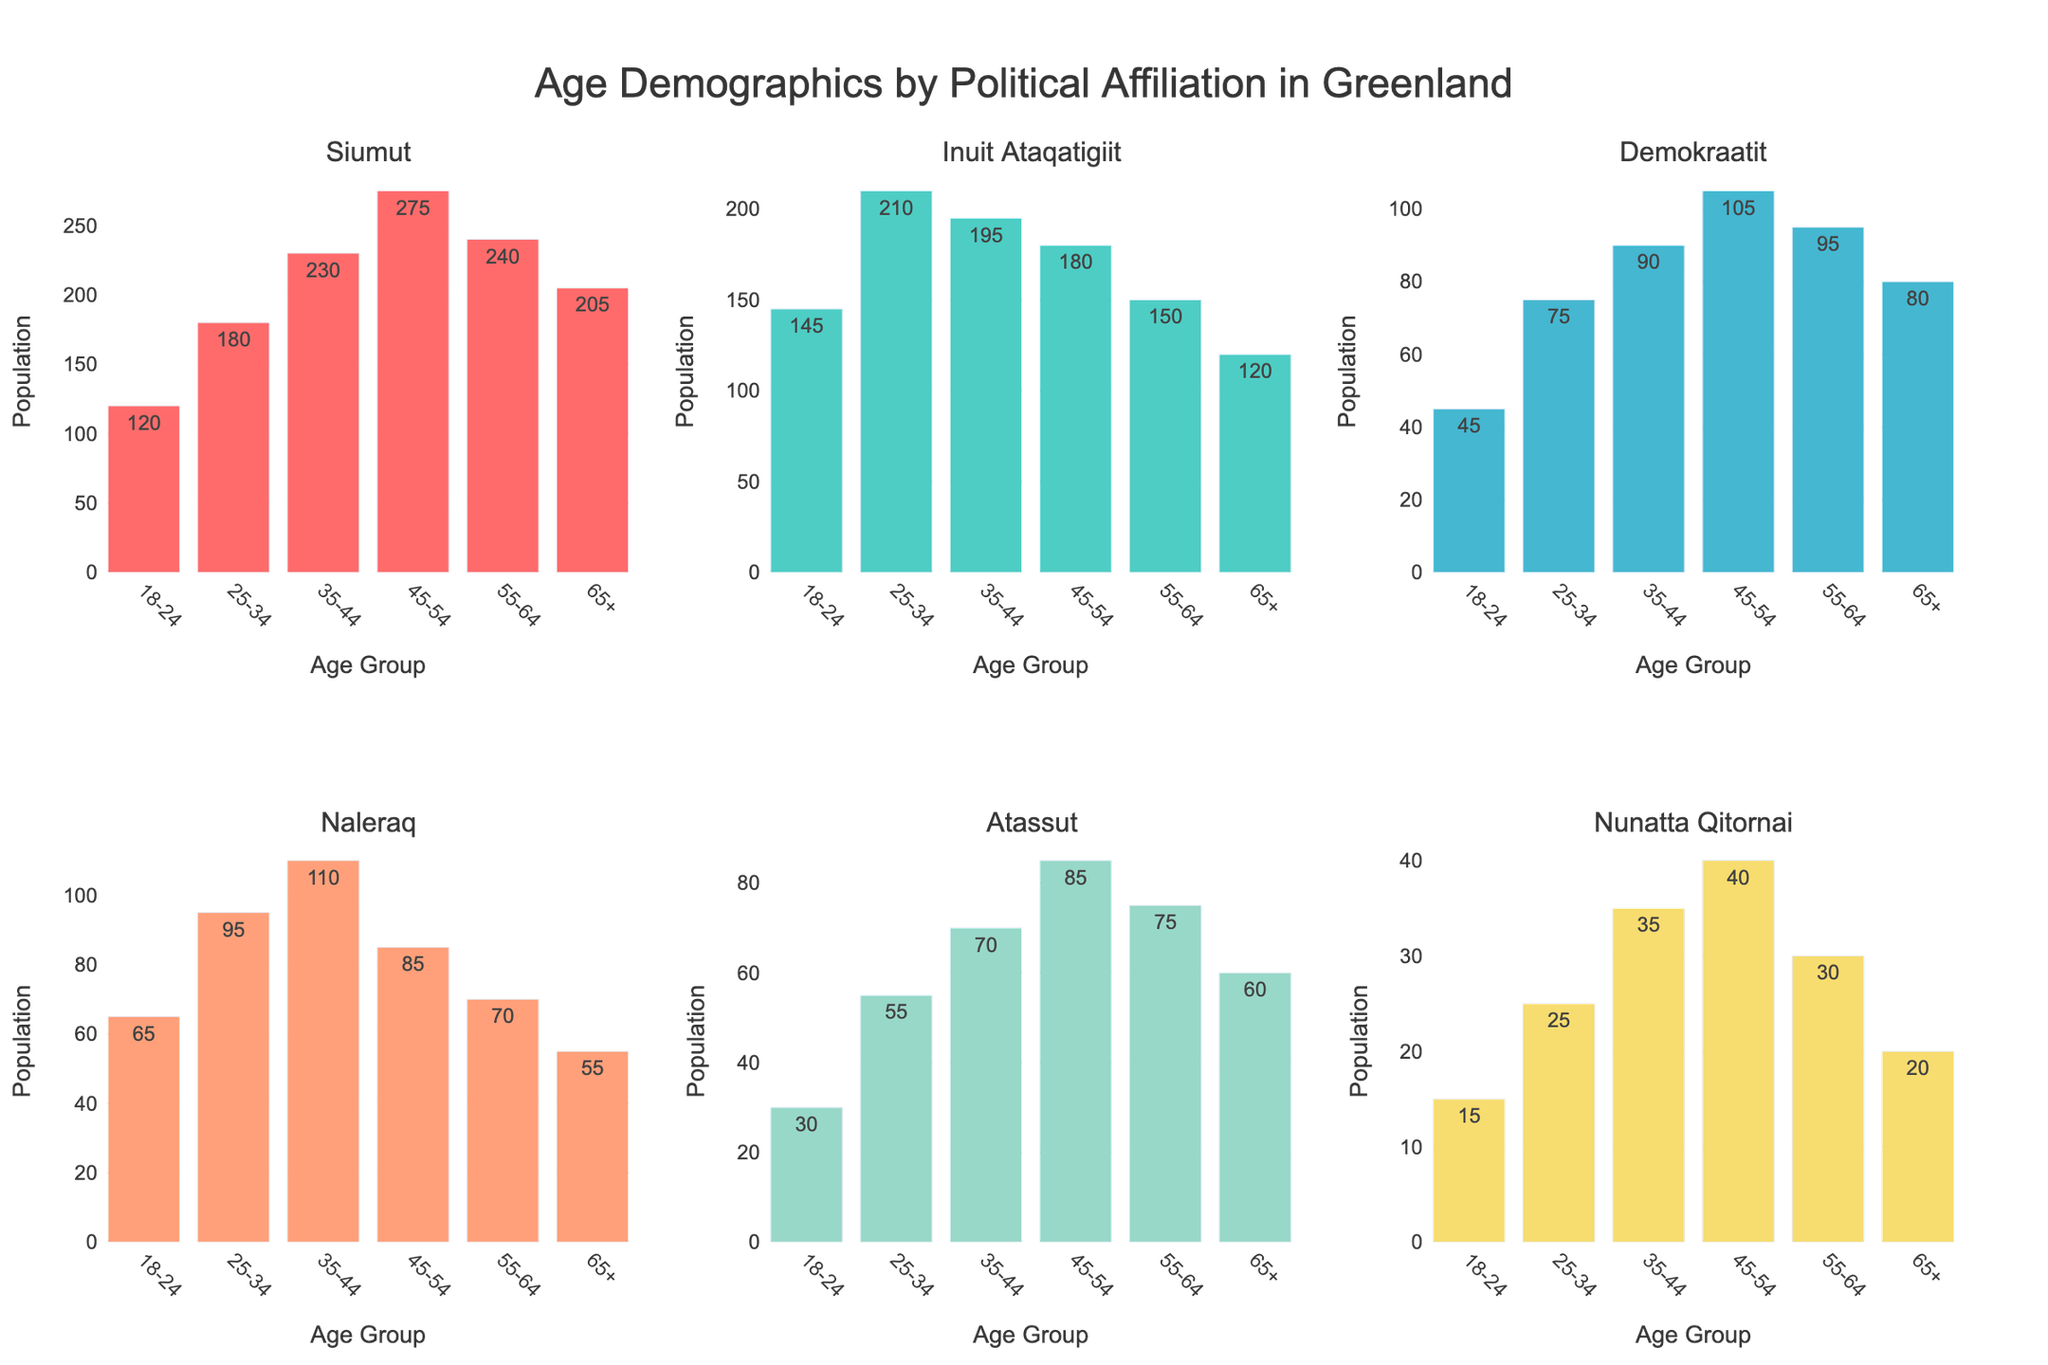What's the title of the figure? The title is usually prominently displayed at the top of the figure. In this case, it says "Age Demographics by Political Affiliation in Greenland".
Answer: Age Demographics by Political Affiliation in Greenland Which political party has the highest number of supporters in the 45-54 age group? Look at the 45-54 age group across all subplots. The highest bar in this age group is for the Siumut party, which has the label of 275.
Answer: Siumut Which age group has the lowest number of supporters for Atassut? Check the subplot for Atassut and compare the height of the bars. The lowest bar is for the 18-24 age group, which has the label of 30.
Answer: 18-24 How does the support for Inuit Ataqatigiit in the 25-34 age group compare to Nunatta Qitornai in the same age group? Look at the 25-34 age group in the Inuit Ataqatigiit and Nunatta Qitornai subplots. Inuit Ataqatigiit has 210 supporters, while Nunatta Qitornai has 25 supporters, so Inuit Ataqatigiit has significantly more.
Answer: Inuit Ataqatigiit has more What's the age group distribution of supporters for Demokraatit? Check the labels for each age group in the Demokraatit subplot: 45 (18-24), 75 (25-34), 90 (35-44), 105 (45-54), 95 (55-64), and 80 (65+). Summarize them in order.
Answer: 18-24: 45, 25-34: 75, 35-44: 90, 45-54: 105, 55-64: 95, 65+: 80 What is the combined number of supporters for Naleraq in the 35-44 and 45-54 age groups? Add the supporters in these age groups in the Naleraq subplot: 110 (35-44) + 85 (45-54) = 195.
Answer: 195 Compare the population of Siumut supporters in the 55-64 and 65+ age groups. Which group is larger? Check the subplot for Siumut and compare the bars for these age groups. 55-64 has 240 supporters, and 65+ has 205 supporters. Thus, the 55-64 group is larger.
Answer: 55-64 What's the average number of supporters across all age groups for Nunatta Qitornai? Add all the numbers for Nunatta Qitornai and divide by the number of age groups (6). (15 + 25 + 35 + 40 + 30 + 20) = 165, so the average is 165 / 6 = 27.5.
Answer: 27.5 